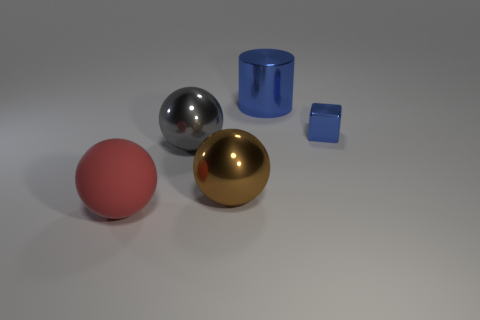What color is the large matte thing that is the same shape as the large brown metal object?
Ensure brevity in your answer.  Red. There is a thing that is behind the small blue metallic block; does it have the same color as the matte thing?
Your response must be concise. No. What number of things are either large things in front of the gray metallic sphere or large cyan rubber objects?
Offer a very short reply. 2. What material is the blue object in front of the thing behind the blue metal thing in front of the blue shiny cylinder?
Keep it short and to the point. Metal. Is the number of large metal cylinders that are behind the large red ball greater than the number of shiny blocks that are behind the large blue shiny object?
Give a very brief answer. Yes. How many cylinders are metallic things or small blue shiny things?
Your response must be concise. 1. How many big gray spheres are behind the big metal object that is on the left side of the large metallic ball that is on the right side of the gray shiny thing?
Keep it short and to the point. 0. What is the material of the block that is the same color as the big metallic cylinder?
Ensure brevity in your answer.  Metal. Is the number of small things greater than the number of tiny red cylinders?
Your answer should be very brief. Yes. Do the brown object and the blue block have the same size?
Your answer should be very brief. No. 